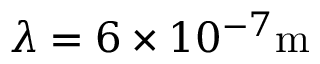Convert formula to latex. <formula><loc_0><loc_0><loc_500><loc_500>\lambda = 6 \times 1 0 ^ { - 7 } m</formula> 